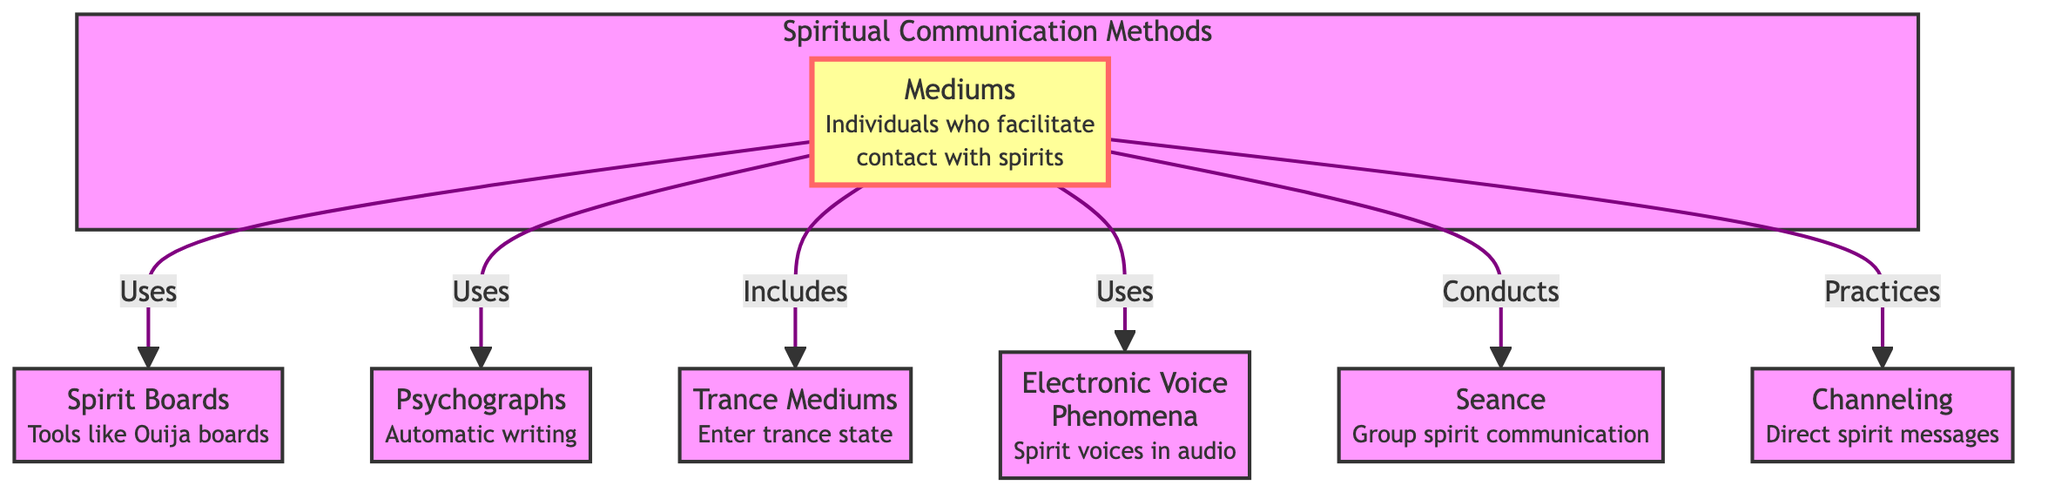What are the types of mediums mentioned in the diagram? The diagram lists "Mediums" as the main node, and from this node, there are several connections to types of mediums. The specific types mentioned are Spirit Boards, Psychographs, Trance Mediums, EVP, Seance, and Channeling.
Answer: Spirit Boards, Psychographs, Trance Mediums, EVP, Seance, Channeling How many types of communication methods are connected to mediums? To find the number of communication methods connected to mediums, count the connections from the "Mediums" node. There are six connections leading to Spirit Boards, Psychographs, Trance Mediums, EVP, Seance, and Channeling.
Answer: 6 What is the relationship between mediums and spirit boards? The diagram indicates a direct relationship where Mediums "Uses" Spirit Boards, showing that spirit boards are a method employed by mediums for communication.
Answer: Uses Which method is categorized under 'Includes' with respect to mediums? The flowchart indicates that "Trance Mediums" is categorized under the relationship "Includes". This illustrates that trance mediums are a subset of the broader category of mediums.
Answer: Trance Mediums What type of communication does 'EVP' represent? The diagram clearly labels EVP as "Electronic Voice Phenomena," denoting it as a method through which spirit voices are captured in audio.
Answer: Spirit voices in audio Which two methods are directly connected through the 'Uses' relationship? By observing the diagram, we can identify that both Spirit Boards and Psychographs are connected via the 'Uses' relationship. This signifies that mediums utilize both methods in their practices.
Answer: Spirit Boards, Psychographs What type of session is implied by 'Seance' in the context of mediums? The diagram describes Seance as a method for "Group spirit communication," suggesting that it involves multiple individuals coming together to communicate with spirits.
Answer: Group spirit communication How are trance mediums different from other types of mediums in the diagram? The relationship depicted in the diagram shows that Trance Mediums fall under the category of "Includes", indicating that they represent a specific practice within the broader mediumship field, as opposed to being direct methods like the others.
Answer: Includes Which category does 'Channeling' fall under in the context of spiritual communication? The diagram shows that Channeling is indicated as a valid practice performed by mediums, illustrating that it is a method for transmitting direct spirit messages.
Answer: Practices 